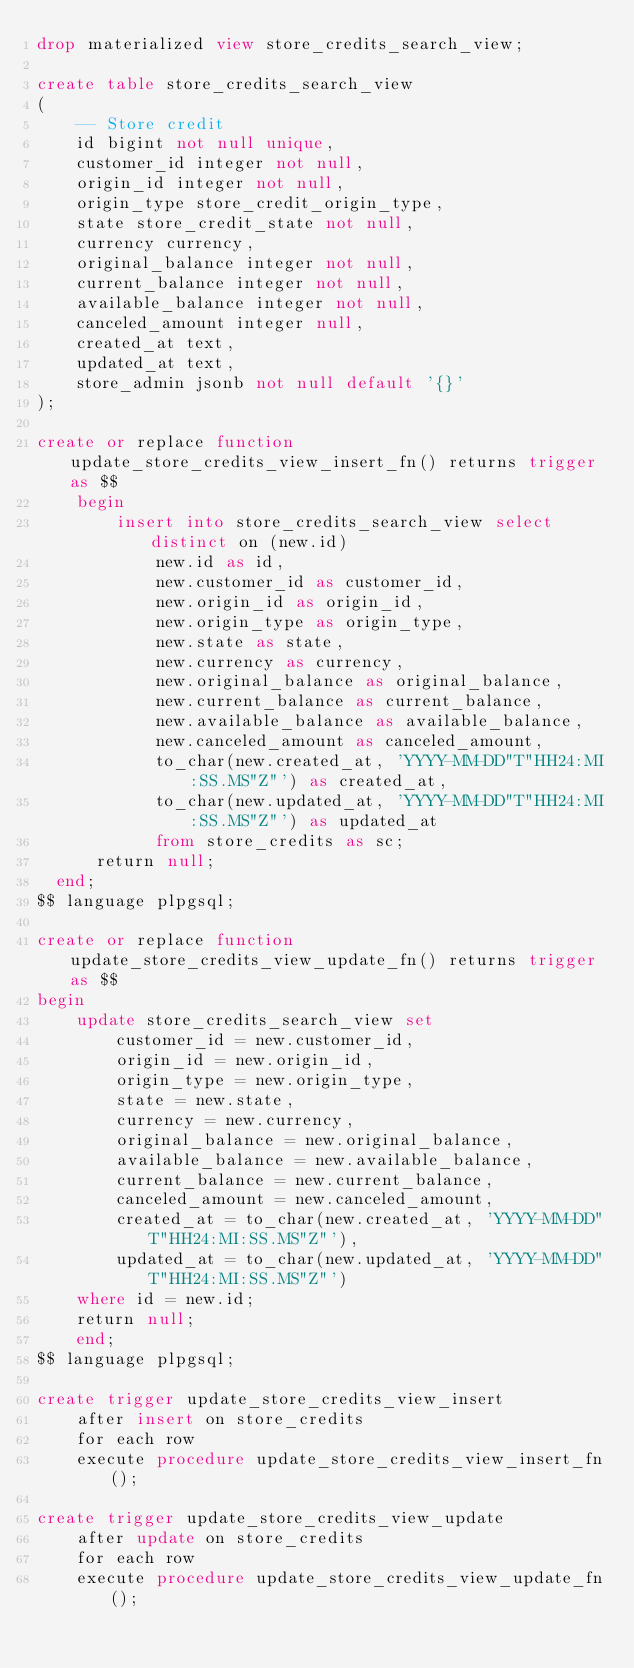<code> <loc_0><loc_0><loc_500><loc_500><_SQL_>drop materialized view store_credits_search_view;

create table store_credits_search_view
(
    -- Store credit
    id bigint not null unique,
    customer_id integer not null,
    origin_id integer not null,
    origin_type store_credit_origin_type,
    state store_credit_state not null,
    currency currency,
    original_balance integer not null,
    current_balance integer not null,
    available_balance integer not null,
    canceled_amount integer null,
    created_at text,
    updated_at text,
    store_admin jsonb not null default '{}'
);

create or replace function update_store_credits_view_insert_fn() returns trigger as $$
    begin
        insert into store_credits_search_view select distinct on (new.id)
            new.id as id,
            new.customer_id as customer_id,
            new.origin_id as origin_id,
            new.origin_type as origin_type,           
            new.state as state,
            new.currency as currency,
            new.original_balance as original_balance,
            new.current_balance as current_balance,
            new.available_balance as available_balance,
            new.canceled_amount as canceled_amount,
            to_char(new.created_at, 'YYYY-MM-DD"T"HH24:MI:SS.MS"Z"') as created_at,
            to_char(new.updated_at, 'YYYY-MM-DD"T"HH24:MI:SS.MS"Z"') as updated_at
            from store_credits as sc;
      return null;
  end;
$$ language plpgsql;

create or replace function update_store_credits_view_update_fn() returns trigger as $$
begin
    update store_credits_search_view set
        customer_id = new.customer_id,
        origin_id = new.origin_id,
        origin_type = new.origin_type,
        state = new.state,
        currency = new.currency,
        original_balance = new.original_balance,
        available_balance = new.available_balance,
        current_balance = new.current_balance,
        canceled_amount = new.canceled_amount,
        created_at = to_char(new.created_at, 'YYYY-MM-DD"T"HH24:MI:SS.MS"Z"'),
        updated_at = to_char(new.updated_at, 'YYYY-MM-DD"T"HH24:MI:SS.MS"Z"')
    where id = new.id;
    return null;
    end;
$$ language plpgsql;

create trigger update_store_credits_view_insert
    after insert on store_credits
    for each row
    execute procedure update_store_credits_view_insert_fn();

create trigger update_store_credits_view_update
    after update on store_credits
    for each row
    execute procedure update_store_credits_view_update_fn();
</code> 